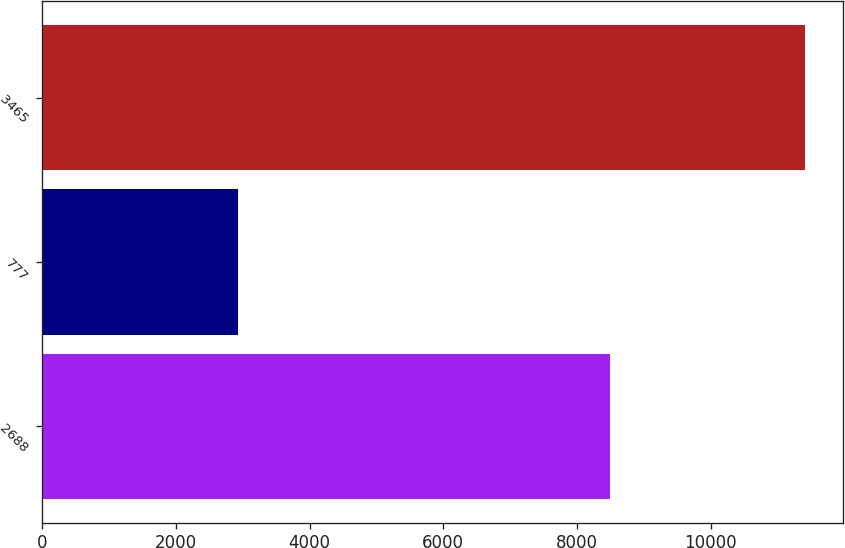Convert chart. <chart><loc_0><loc_0><loc_500><loc_500><bar_chart><fcel>2688<fcel>777<fcel>3465<nl><fcel>8485<fcel>2924<fcel>11409<nl></chart> 